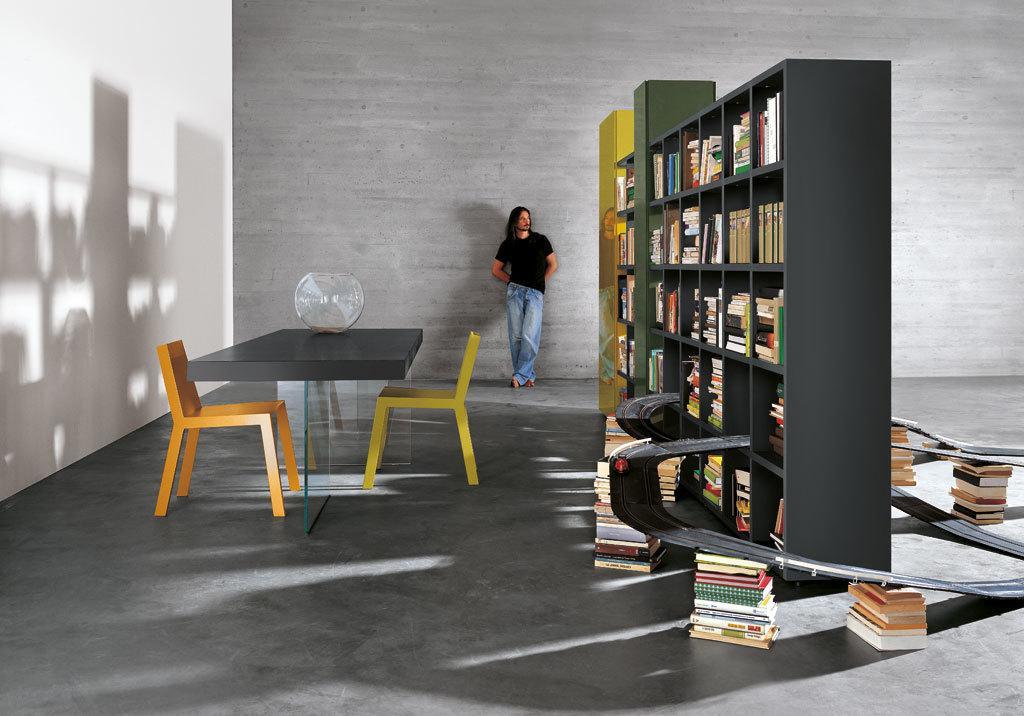How would you summarize this image in a sentence or two? As we can see in the image, there is a man standing on floor and there is a brown color table and two chairs and there is a rack. The rack is filled with books and on the left side the wall is in white color. 